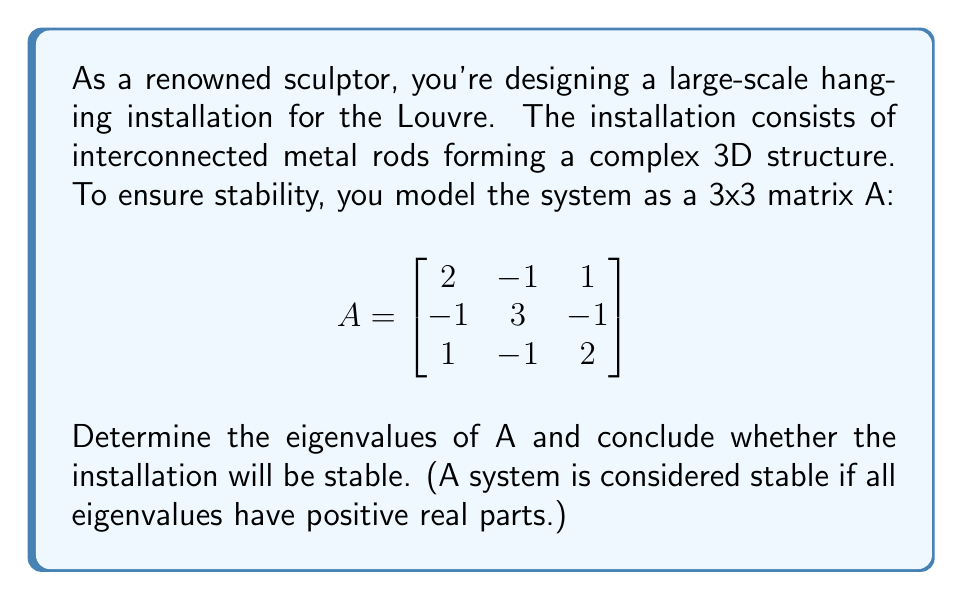Provide a solution to this math problem. To analyze the stability of the installation, we need to find the eigenvalues of matrix A.

Step 1: Set up the characteristic equation
$det(A - \lambda I) = 0$

Step 2: Expand the determinant
$$\begin{vmatrix}
2-\lambda & -1 & 1 \\
-1 & 3-\lambda & -1 \\
1 & -1 & 2-\lambda
\end{vmatrix} = 0$$

Step 3: Calculate the determinant
$(2-\lambda)[(3-\lambda)(2-\lambda) - 1] + (-1)[(-1)(2-\lambda) - 1] + 1[(-1)(-1) - (3-\lambda)] = 0$

Step 4: Simplify
$(2-\lambda)[(6-5\lambda+\lambda^2) - 1] + (-1)[-2+\lambda - 1] + 1[1 - 3+\lambda] = 0$
$(2-\lambda)(5-5\lambda+\lambda^2) + (-1)[-3+\lambda] + [-2+\lambda] = 0$
$10-10\lambda+2\lambda^2-5\lambda+5\lambda^2-\lambda^3+3-\lambda-2+\lambda = 0$

Step 5: Combine like terms
$-\lambda^3+7\lambda^2-15\lambda+11 = 0$

Step 6: Factor the cubic equation
$(\lambda-1)(\lambda-3)(\lambda-3) = 0$

Step 7: Solve for $\lambda$
$\lambda_1 = 1, \lambda_2 = 3, \lambda_3 = 3$

Step 8: Analyze stability
All eigenvalues are positive real numbers, therefore the system is stable.
Answer: Eigenvalues: 1, 3, 3. System is stable. 